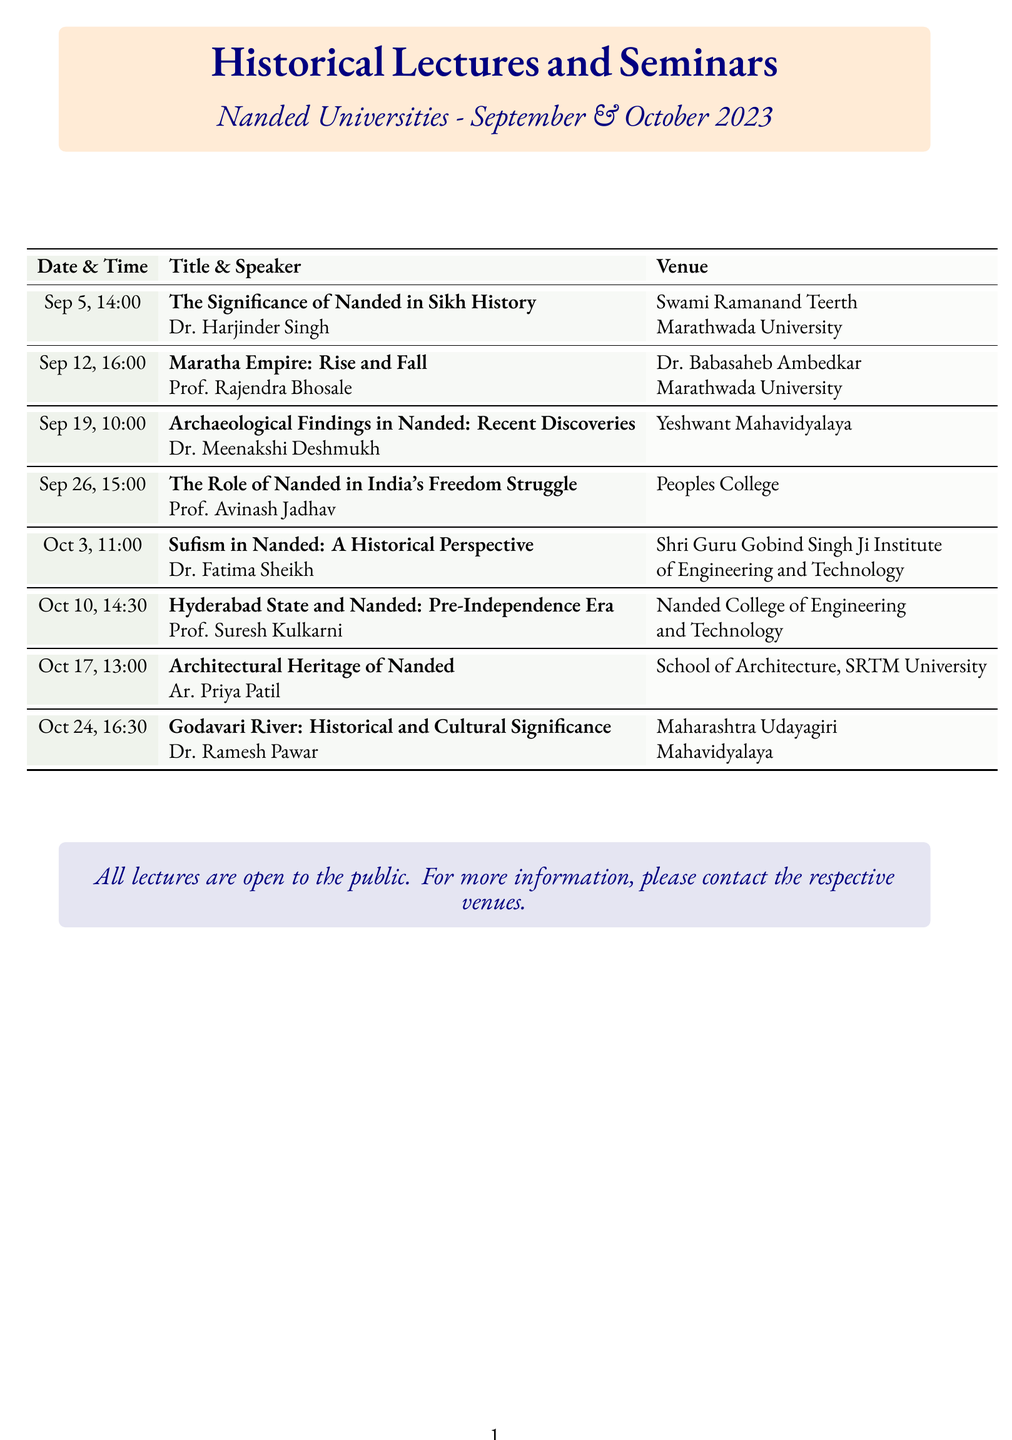What is the date of the lecture on Sikh history? The date mentioned for the lecture "The Significance of Nanded in Sikh History" is September 5, 2023.
Answer: September 5, 2023 Who is the speaker for the seminar on Sufism? The document lists Dr. Fatima Sheikh as the speaker for the seminar titled "Sufism in Nanded: A Historical Perspective."
Answer: Dr. Fatima Sheikh At which venue is the lecture on Nanded's architectural heritage held? The lecture titled "Architectural Heritage of Nanded" is hosted at the School of Architecture, Swami Ramanand Teerth Marathwada University.
Answer: School of Architecture, Swami Ramanand Teerth Marathwada University What time does the seminar on the Godavari River start? The seminar titled "Godavari River: Historical and Cultural Significance" starts at 16:30.
Answer: 16:30 How many lectures occur in October 2023? The document outlines four lectures scheduled for October 2023.
Answer: Four Which university is associated with the seminar on archaeological findings? The seminar "Archaeological Findings in Nanded: Recent Discoveries" is held at Yeshwant Mahavidyalaya.
Answer: Yeshwant Mahavidyalaya What is the theme of the lecture on September 12? The theme of the lecture on September 12 is about the history of the Maratha Empire.
Answer: Maratha Empire: Rise and Fall How many total seminars are listed in the document? There are a total of eight seminars listed in the schedule.
Answer: Eight 